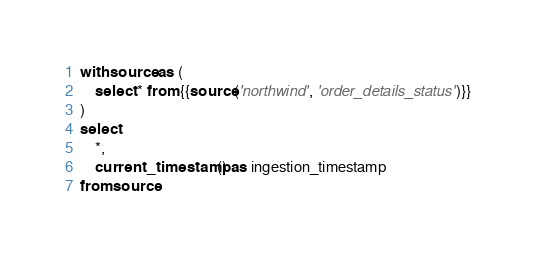Convert code to text. <code><loc_0><loc_0><loc_500><loc_500><_SQL_>with source as (
    select * from {{source('northwind', 'order_details_status')}}
)
select 
    *,
    current_timestamp() as ingestion_timestamp 
from source</code> 